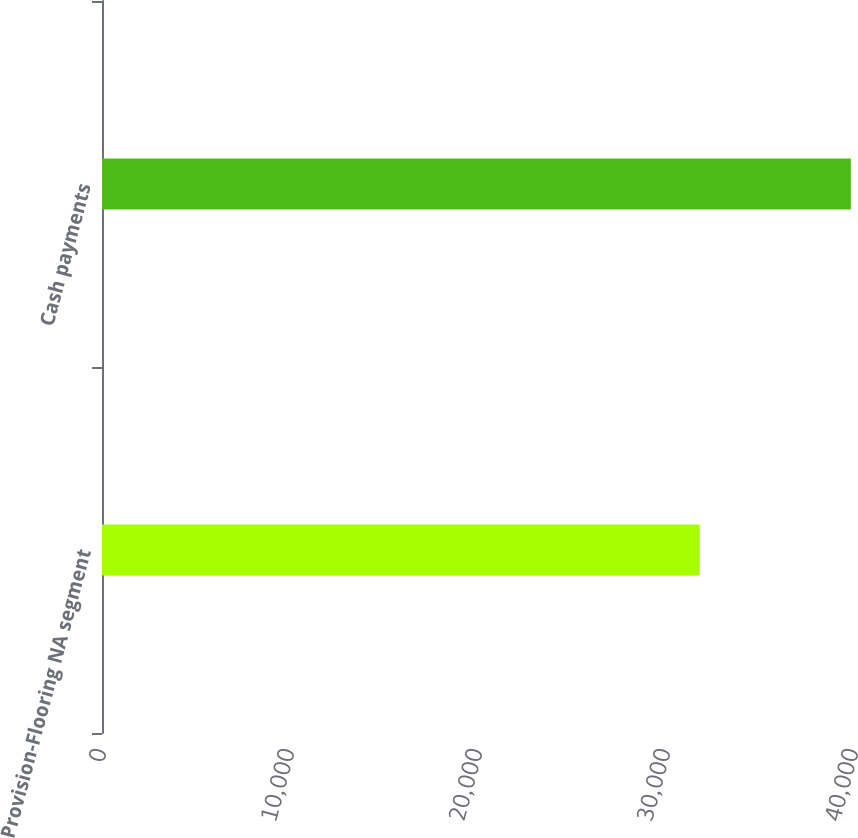Convert chart. <chart><loc_0><loc_0><loc_500><loc_500><bar_chart><fcel>Provision-Flooring NA segment<fcel>Cash payments<nl><fcel>31796<fcel>39833<nl></chart> 